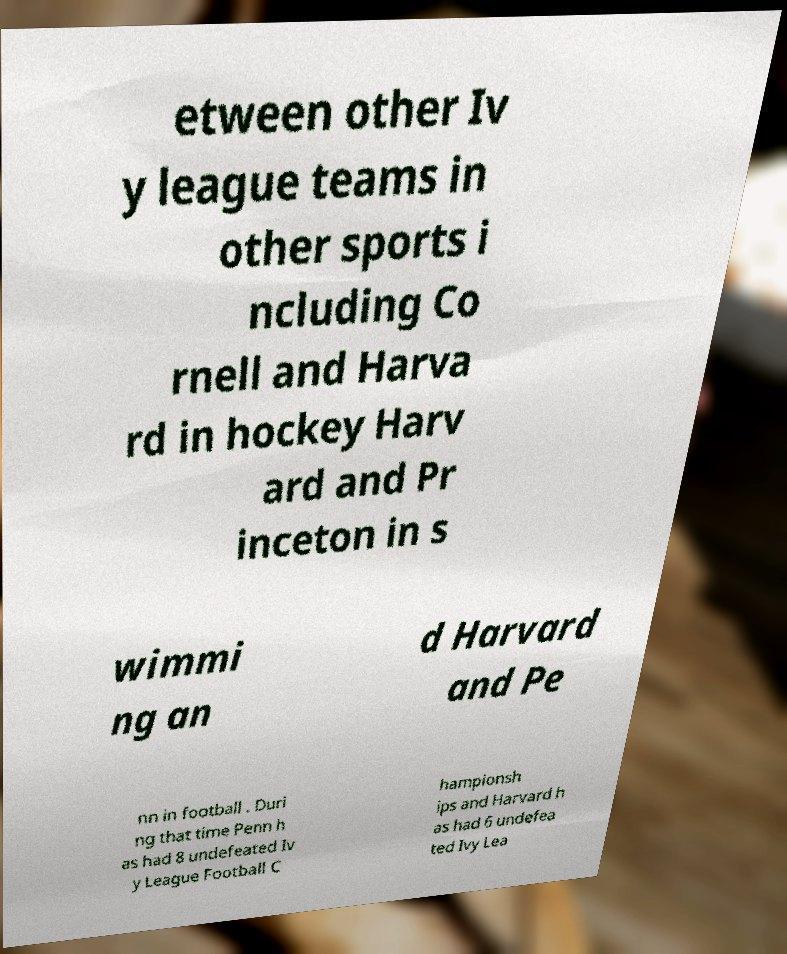Can you accurately transcribe the text from the provided image for me? etween other Iv y league teams in other sports i ncluding Co rnell and Harva rd in hockey Harv ard and Pr inceton in s wimmi ng an d Harvard and Pe nn in football . Duri ng that time Penn h as had 8 undefeated Iv y League Football C hampionsh ips and Harvard h as had 6 undefea ted Ivy Lea 